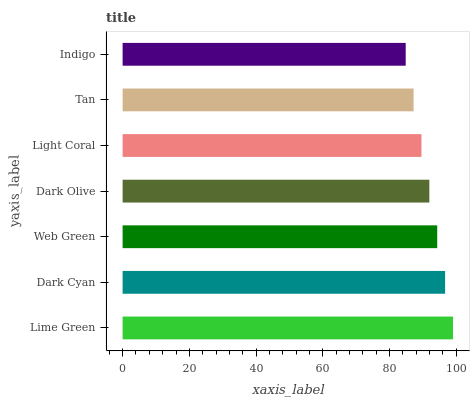Is Indigo the minimum?
Answer yes or no. Yes. Is Lime Green the maximum?
Answer yes or no. Yes. Is Dark Cyan the minimum?
Answer yes or no. No. Is Dark Cyan the maximum?
Answer yes or no. No. Is Lime Green greater than Dark Cyan?
Answer yes or no. Yes. Is Dark Cyan less than Lime Green?
Answer yes or no. Yes. Is Dark Cyan greater than Lime Green?
Answer yes or no. No. Is Lime Green less than Dark Cyan?
Answer yes or no. No. Is Dark Olive the high median?
Answer yes or no. Yes. Is Dark Olive the low median?
Answer yes or no. Yes. Is Lime Green the high median?
Answer yes or no. No. Is Indigo the low median?
Answer yes or no. No. 